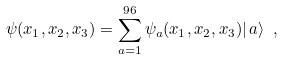<formula> <loc_0><loc_0><loc_500><loc_500>\psi ( { x } _ { 1 } , { x } _ { 2 } , { x } _ { 3 } ) = \sum _ { a = 1 } ^ { 9 6 } \psi _ { a } ( { x } _ { 1 } , { x } _ { 2 } , { x } _ { 3 } ) | \, a \rangle \ ,</formula> 